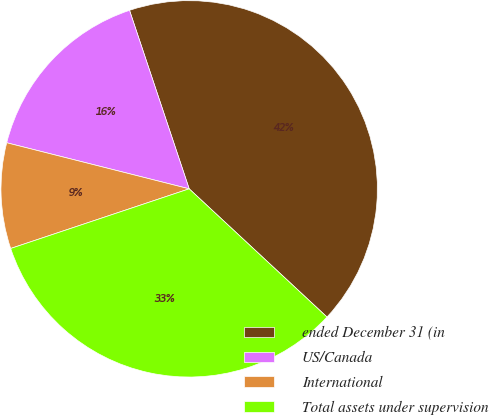<chart> <loc_0><loc_0><loc_500><loc_500><pie_chart><fcel>ended December 31 (in<fcel>US/Canada<fcel>International<fcel>Total assets under supervision<nl><fcel>42.06%<fcel>15.93%<fcel>9.07%<fcel>32.94%<nl></chart> 